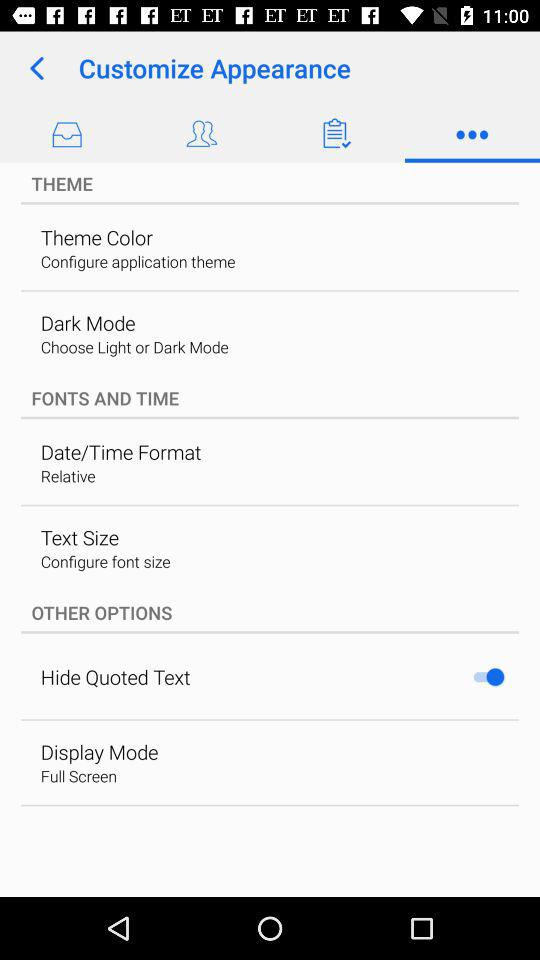How many items have a switch in the 'Other Options' section?
Answer the question using a single word or phrase. 1 